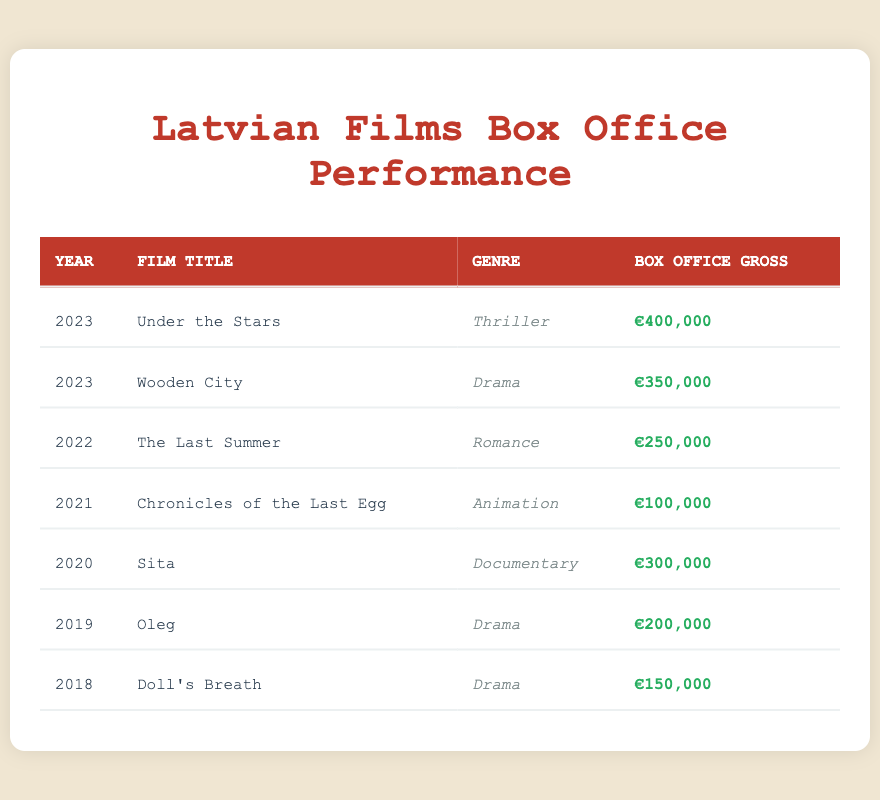What is the highest box office gross achieved by a Latvian film? The table lists the box office gross for each film. The highest value is €400,000 from the film "Under the Stars" released in 2023.
Answer: €400,000 Which genre garnered the highest revenue in 2023? In 2023, "Under the Stars" (Thriller) grossed €400,000 and "Wooden City" (Drama) grossed €350,000. The Thriller genre had the highest revenue.
Answer: Thriller How many films were released in 2022? The table indicates one film released in 2022, which is "The Last Summer."
Answer: 1 What is the average box office gross for Latvian films released between 2018 and 2020? The films from 2018 to 2020 grossed €150,000 (2018) + €200,000 (2019) + €300,000 (2020) = €650,000. There are 3 films, so the average gross is €650,000 / 3 = €216,667.
Answer: €216,667 Did "Oleg" achieve a box office gross greater than or equal to €250,000? The film "Oleg" grossed €200,000, which is less than €250,000, so the statement is false.
Answer: No List the total box office gross from films in the Drama genre. The Drama films are "Doll's Breath" (€150,000), "Oleg" (€200,000), and "Wooden City" (€350,000). Their total gross is €150,000 + €200,000 + €350,000 = €700,000.
Answer: €700,000 What percentage of the total box office gross for 2023 did "Wooden City" contribute? The total gross for 2023 is €400,000 (Under the Stars) + €350,000 (Wooden City) = €750,000. "Wooden City" contributed €350,000, which is (€350,000 / €750,000) * 100 = 46.67%.
Answer: 46.67% Which year had the lowest box office performance for a single film? The year 2021 had the lowest gross with "Chronicles of the Last Egg," which earned €100,000, making it the lowest performance of any single film in a year.
Answer: 2021 How many films in the table fall under the genre "Documentary"? The only film in the "Documentary" genre is "Sita," making the count 1.
Answer: 1 Which film had the second highest box office gross and what was its gross? The second highest gross is from "Wooden City," which earned €350,000, ranking right after "Under the Stars."
Answer: €350,000 